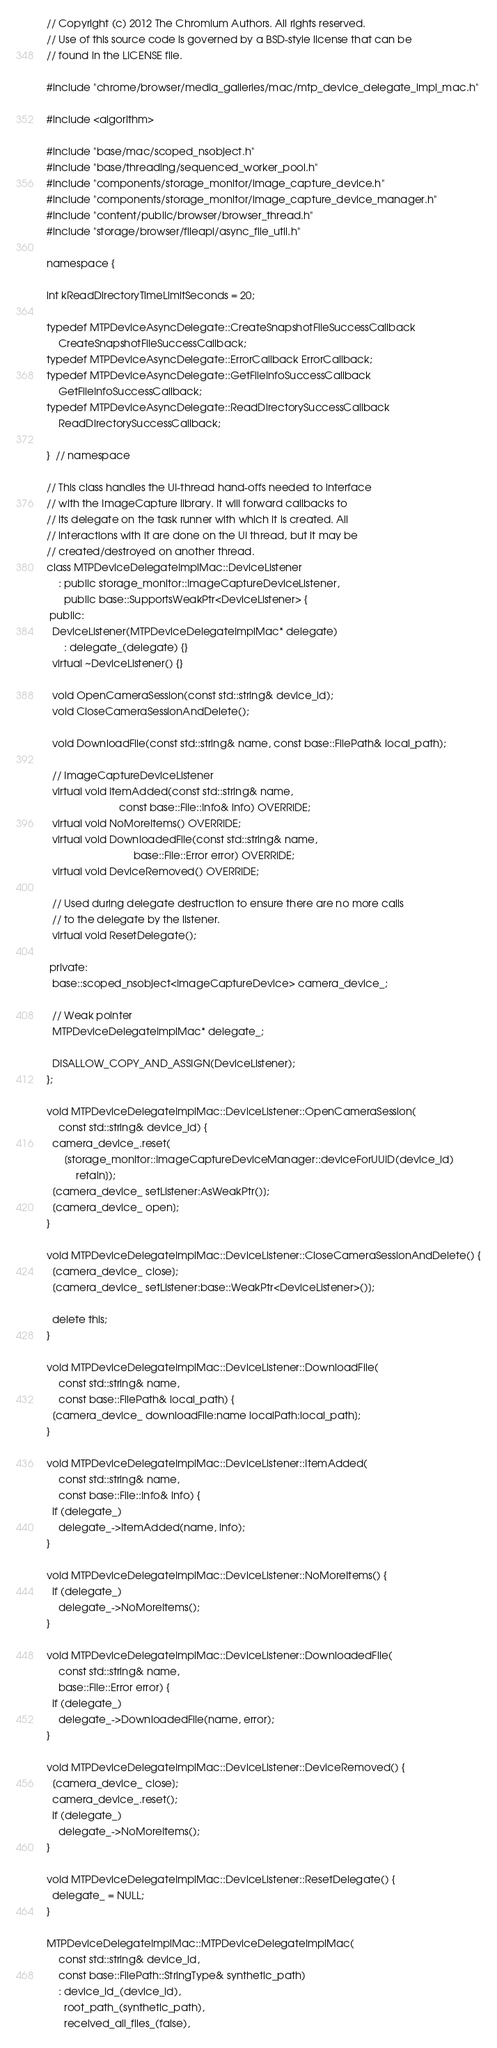Convert code to text. <code><loc_0><loc_0><loc_500><loc_500><_ObjectiveC_>// Copyright (c) 2012 The Chromium Authors. All rights reserved.
// Use of this source code is governed by a BSD-style license that can be
// found in the LICENSE file.

#include "chrome/browser/media_galleries/mac/mtp_device_delegate_impl_mac.h"

#include <algorithm>

#include "base/mac/scoped_nsobject.h"
#include "base/threading/sequenced_worker_pool.h"
#include "components/storage_monitor/image_capture_device.h"
#include "components/storage_monitor/image_capture_device_manager.h"
#include "content/public/browser/browser_thread.h"
#include "storage/browser/fileapi/async_file_util.h"

namespace {

int kReadDirectoryTimeLimitSeconds = 20;

typedef MTPDeviceAsyncDelegate::CreateSnapshotFileSuccessCallback
    CreateSnapshotFileSuccessCallback;
typedef MTPDeviceAsyncDelegate::ErrorCallback ErrorCallback;
typedef MTPDeviceAsyncDelegate::GetFileInfoSuccessCallback
    GetFileInfoSuccessCallback;
typedef MTPDeviceAsyncDelegate::ReadDirectorySuccessCallback
    ReadDirectorySuccessCallback;

}  // namespace

// This class handles the UI-thread hand-offs needed to interface
// with the ImageCapture library. It will forward callbacks to
// its delegate on the task runner with which it is created. All
// interactions with it are done on the UI thread, but it may be
// created/destroyed on another thread.
class MTPDeviceDelegateImplMac::DeviceListener
    : public storage_monitor::ImageCaptureDeviceListener,
      public base::SupportsWeakPtr<DeviceListener> {
 public:
  DeviceListener(MTPDeviceDelegateImplMac* delegate)
      : delegate_(delegate) {}
  virtual ~DeviceListener() {}

  void OpenCameraSession(const std::string& device_id);
  void CloseCameraSessionAndDelete();

  void DownloadFile(const std::string& name, const base::FilePath& local_path);

  // ImageCaptureDeviceListener
  virtual void ItemAdded(const std::string& name,
                         const base::File::Info& info) OVERRIDE;
  virtual void NoMoreItems() OVERRIDE;
  virtual void DownloadedFile(const std::string& name,
                              base::File::Error error) OVERRIDE;
  virtual void DeviceRemoved() OVERRIDE;

  // Used during delegate destruction to ensure there are no more calls
  // to the delegate by the listener.
  virtual void ResetDelegate();

 private:
  base::scoped_nsobject<ImageCaptureDevice> camera_device_;

  // Weak pointer
  MTPDeviceDelegateImplMac* delegate_;

  DISALLOW_COPY_AND_ASSIGN(DeviceListener);
};

void MTPDeviceDelegateImplMac::DeviceListener::OpenCameraSession(
    const std::string& device_id) {
  camera_device_.reset(
      [storage_monitor::ImageCaptureDeviceManager::deviceForUUID(device_id)
          retain]);
  [camera_device_ setListener:AsWeakPtr()];
  [camera_device_ open];
}

void MTPDeviceDelegateImplMac::DeviceListener::CloseCameraSessionAndDelete() {
  [camera_device_ close];
  [camera_device_ setListener:base::WeakPtr<DeviceListener>()];

  delete this;
}

void MTPDeviceDelegateImplMac::DeviceListener::DownloadFile(
    const std::string& name,
    const base::FilePath& local_path) {
  [camera_device_ downloadFile:name localPath:local_path];
}

void MTPDeviceDelegateImplMac::DeviceListener::ItemAdded(
    const std::string& name,
    const base::File::Info& info) {
  if (delegate_)
    delegate_->ItemAdded(name, info);
}

void MTPDeviceDelegateImplMac::DeviceListener::NoMoreItems() {
  if (delegate_)
    delegate_->NoMoreItems();
}

void MTPDeviceDelegateImplMac::DeviceListener::DownloadedFile(
    const std::string& name,
    base::File::Error error) {
  if (delegate_)
    delegate_->DownloadedFile(name, error);
}

void MTPDeviceDelegateImplMac::DeviceListener::DeviceRemoved() {
  [camera_device_ close];
  camera_device_.reset();
  if (delegate_)
    delegate_->NoMoreItems();
}

void MTPDeviceDelegateImplMac::DeviceListener::ResetDelegate() {
  delegate_ = NULL;
}

MTPDeviceDelegateImplMac::MTPDeviceDelegateImplMac(
    const std::string& device_id,
    const base::FilePath::StringType& synthetic_path)
    : device_id_(device_id),
      root_path_(synthetic_path),
      received_all_files_(false),</code> 